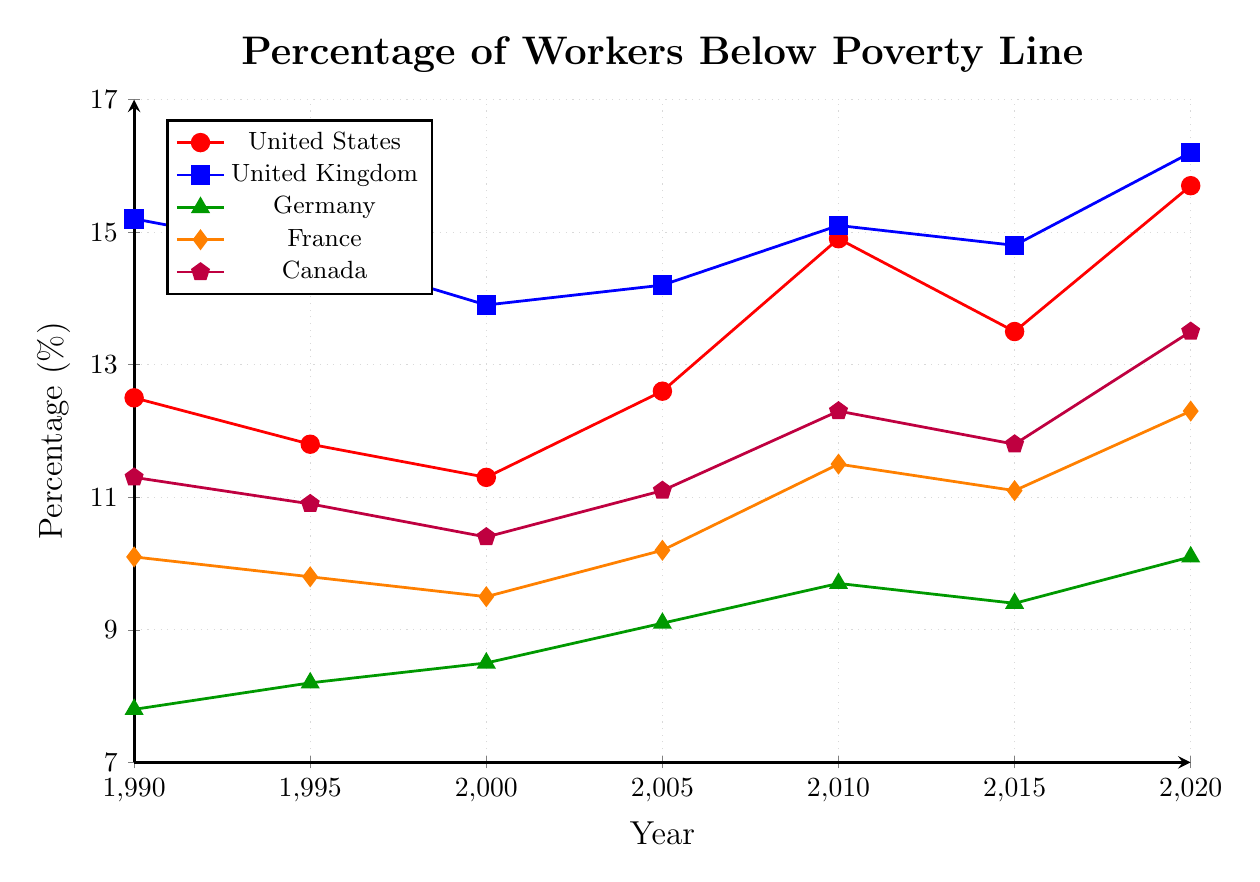Which country had the highest percentage of workers living below the poverty line in 2020? The highest percentage visually corresponds to the blue line with a value of 16.2%.
Answer: United Kingdom Which country shows the largest increase in the percentage of workers living below the poverty line from 1990 to 2020? By visually comparing the starting and ending points, the United States (red line) increased from 12.5% to 15.7% (3.2%), the United Kingdom (blue line) from 15.2% to 16.2% (1%), Germany (green line) from 7.8% to 10.1% (2.3%), France (orange line) from 10.1% to 12.3% (2.2%), and Canada (purple line) from 11.3% to 13.5% (2.2%). The United States shows the largest increase.
Answer: United States What was the trend for workers living below the poverty line in France from 1990 to 2020? The trend in France, represented by the orange line, shows a slight decrease from 1990 (10.1%) to 2000 (9.5%) followed by a general increase up to 2020 (12.3%).
Answer: Increasing trend Among the five countries, which had the lowest percentage of workers living below the poverty line in 2000, and what was the percentage? By inspecting the values for the year 2000, Germany (green line) has the lowest percentage at 8.5%.
Answer: Germany, 8.5% How does the trend in the percentage of workers living below the poverty line for Canada from 1990 to 2020 compare to Germany? The trend for Canada (purple line) shows fluctuating values but overall increase from 11.3% to 13.5%. Germany (green line) shows a steady increase from 7.8% to 10.1%. Both show an increasing trend, but Germany's increase is steadier while Canada's is more fluctuating.
Answer: Both increase, but Germany's trend is steadier What is the difference in the percentage of workers living below the poverty line between the United States and Germany in 2010? In 2010, the percentage for the United States (red line) is 14.9%, and for Germany (green line) it is 9.7%. The difference is 14.9% - 9.7% = 5.2%.
Answer: 5.2% What is the average percentage of workers living below the poverty line in the United Kingdom across all years shown? Summing the values for the UK (15.2 + 14.7 + 13.9 + 14.2 + 15.1 + 14.8 + 16.2) = 104.1, and dividing by the number of data points (7), the average is 104.1/7 ≈ 14.87%.
Answer: 14.87% Which country had a decrease in the percentage of workers living below the poverty line between 1995 and 2000, and what was the decrease? By comparing the values between 1995 and 2000, the United States decreased from 11.8% to 11.3% (0.5%), the United Kingdom from 14.7% to 13.9% (0.8%), and France from 9.8% to 9.5% (0.3%). The United Kingdom had the largest decrease of 0.8%.
Answer: United Kingdom, 0.8% Which country had a relatively stable percentage of workers living below the poverty line from 2000 to 2010? Visual inspection of stability around a constant value indicates Germany (green line) showing values 8.5% to 9.7%, with only slight increases each interval.
Answer: Germany 